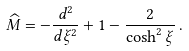<formula> <loc_0><loc_0><loc_500><loc_500>\widehat { M } = - \frac { d ^ { 2 } } { d \xi ^ { 2 } } + 1 - \frac { 2 } { \cosh ^ { 2 } \xi } \, .</formula> 